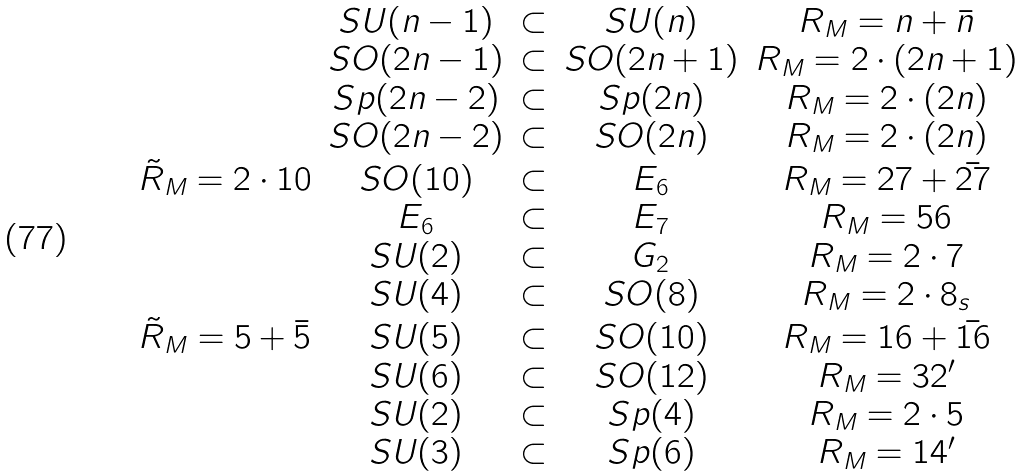<formula> <loc_0><loc_0><loc_500><loc_500>\begin{array} { c c c c c } & S U ( n - 1 ) & \subset & S U ( n ) & R _ { M } = { n } + { \bar { n } } \\ & S O ( 2 n - 1 ) & \subset & S O ( 2 n + 1 ) & R _ { M } = 2 \cdot { ( 2 n + 1 ) } \\ & S p ( 2 n - 2 ) & \subset & S p ( 2 n ) & R _ { M } = 2 \cdot { ( 2 n ) } \\ & S O ( 2 n - 2 ) & \subset & S O ( 2 n ) & R _ { M } = 2 \cdot { ( 2 n ) } \\ \tilde { R } _ { M } = 2 \cdot { 1 0 } & S O ( 1 0 ) & \subset & E _ { 6 } & R _ { M } = { 2 7 } + { \bar { 2 7 } } \\ & E _ { 6 } & \subset & E _ { 7 } & R _ { M } = { 5 6 } \\ & S U ( 2 ) & \subset & G _ { 2 } & R _ { M } = 2 \cdot { 7 } \\ & S U ( 4 ) & \subset & S O ( 8 ) & R _ { M } = 2 \cdot { 8 } _ { s } \\ \tilde { R } _ { M } = { 5 } + { \bar { 5 } } & S U ( 5 ) & \subset & S O ( 1 0 ) & R _ { M } = { 1 6 } + { \bar { 1 6 } } \\ & S U ( 6 ) & \subset & S O ( 1 2 ) & R _ { M } = { 3 2 } ^ { \prime } \\ & S U ( 2 ) & \subset & S p ( 4 ) & R _ { M } = 2 \cdot { 5 } \\ & S U ( 3 ) & \subset & S p ( 6 ) & R _ { M } = { 1 4 } ^ { \prime } \end{array}</formula> 